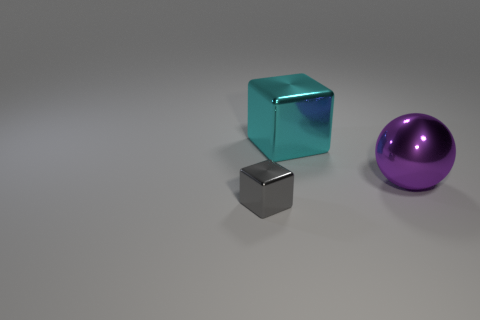How many things are shiny cubes on the right side of the small shiny block or shiny blocks behind the large purple metal object?
Ensure brevity in your answer.  1. There is a thing that is left of the large ball and in front of the big block; what size is it?
Your answer should be very brief. Small. Does the big object that is to the left of the large purple ball have the same shape as the purple metal thing?
Provide a short and direct response. No. There is a metallic thing that is behind the large thing that is in front of the big object left of the large purple metallic ball; what size is it?
Offer a very short reply. Large. How many objects are purple metallic spheres or tiny gray cubes?
Keep it short and to the point. 2. What shape is the object that is to the right of the small gray object and left of the sphere?
Keep it short and to the point. Cube. There is a small gray metal thing; is it the same shape as the big metal object on the right side of the big cube?
Provide a succinct answer. No. Are there any blocks behind the big purple shiny object?
Make the answer very short. Yes. How many cylinders are big purple objects or small gray metallic objects?
Give a very brief answer. 0. Do the large purple shiny thing and the cyan metallic object have the same shape?
Your answer should be compact. No. 